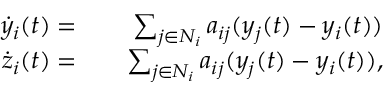Convert formula to latex. <formula><loc_0><loc_0><loc_500><loc_500>\begin{array} { r l r } { \dot { y } _ { i } ( t ) = } & { \sum _ { j \in N _ { i } } a _ { i j } ( y _ { j } ( t ) - y _ { i } ( t ) ) } \\ { \dot { z } _ { i } ( t ) = } & { \sum _ { j \in N _ { i } } a _ { i j } ( y _ { j } ( t ) - y _ { i } ( t ) ) , } \end{array}</formula> 